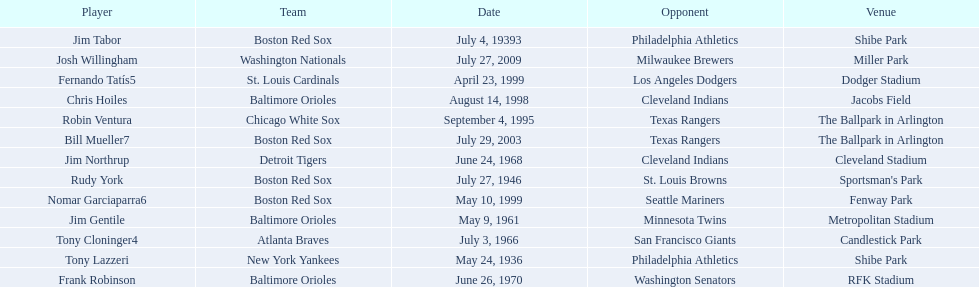Who are the opponents of the boston red sox during baseball home run records? Philadelphia Athletics, St. Louis Browns, Seattle Mariners, Texas Rangers. Of those which was the opponent on july 27, 1946? St. Louis Browns. 